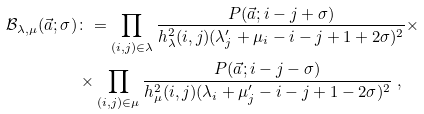Convert formula to latex. <formula><loc_0><loc_0><loc_500><loc_500>{ \mathcal { B } } _ { \lambda , \mu } ( \vec { a } ; \sigma ) & \colon = \prod _ { ( i , j ) \in \lambda } \frac { P ( \vec { a } ; i - j + \sigma ) } { h _ { \lambda } ^ { 2 } ( i , j ) ( \lambda ^ { \prime } _ { j } + \mu _ { i } - i - j + 1 + 2 \sigma ) ^ { 2 } } \times \\ & \times \prod _ { ( i , j ) \in \mu } \frac { P ( \vec { a } ; i - j - \sigma ) } { h _ { \mu } ^ { 2 } ( i , j ) ( \lambda _ { i } + \mu ^ { \prime } _ { j } - i - j + 1 - 2 \sigma ) ^ { 2 } } \ ,</formula> 